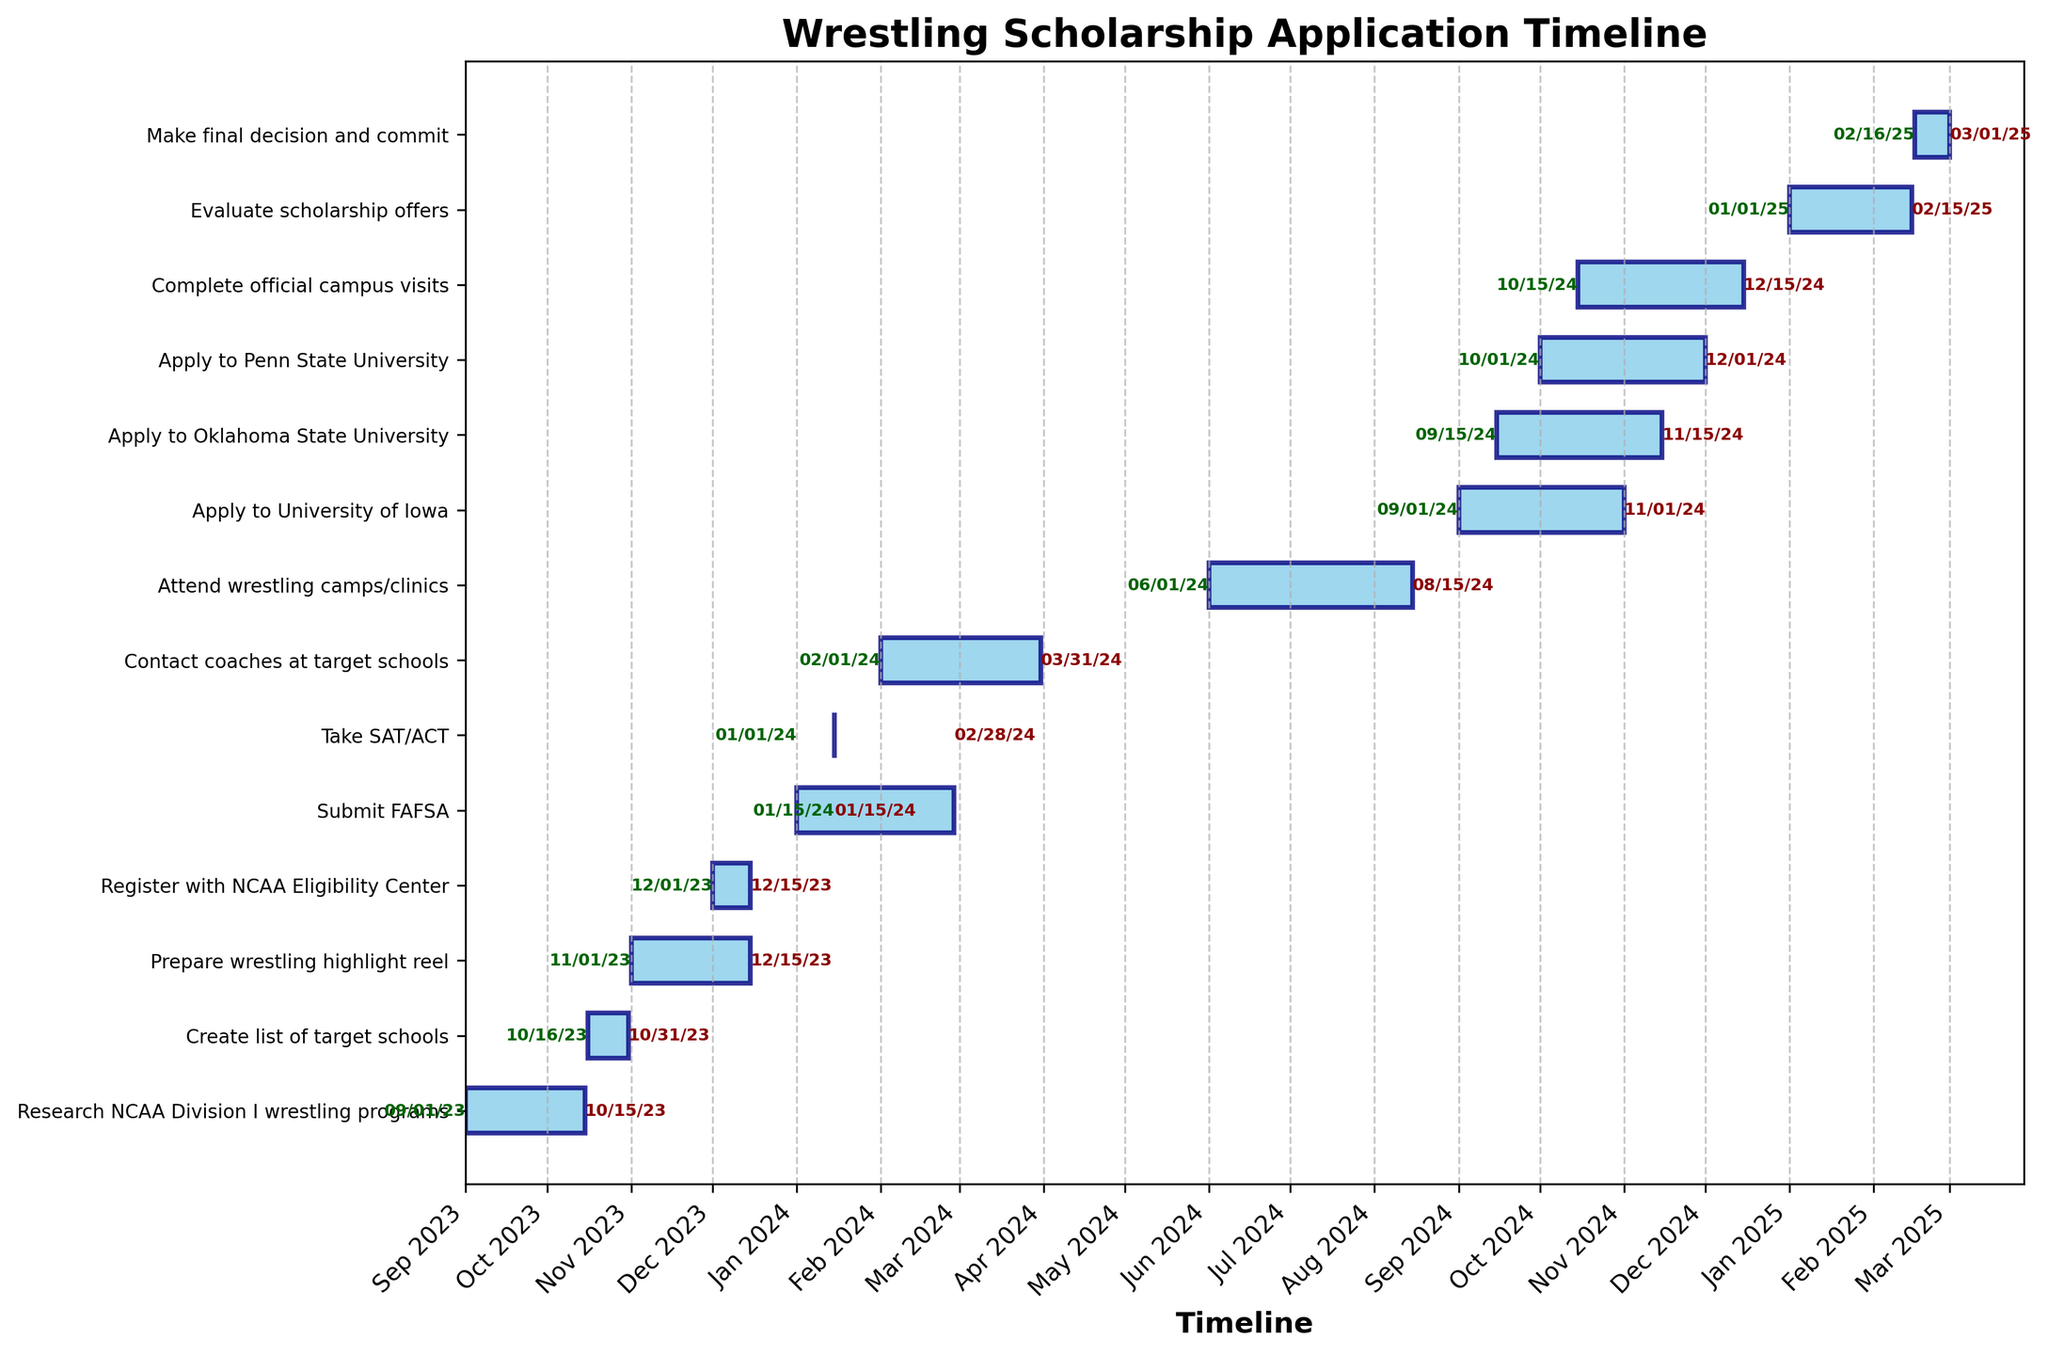Which task ends earliest? To determine the earliest ending task, check the end dates of all tasks and identify the one that occurs first on the timeline.
Answer: Research NCAA Division I wrestling programs What is the duration of preparing the wrestling highlight reel? Look at the start and end dates for "Prepare wrestling highlight reel" to calculate the duration. From 2023-11-01 to 2023-12-15 is 45 days.
Answer: 45 days How many tasks start in September 2024? To find the number of tasks starting in September 2024, check the start dates and count the tasks starting within that month.
Answer: 1 Which task starts right after registering with NCAA Eligibility Center? Look at the end date of "Register with NCAA Eligibility Center" and find the next task that starts immediately after this end date. "Take SAT/ACT" starts on 2024-01-15, following the end date of 2023-12-15 for NCAA Eligibility Center registration.
Answer: Take SAT/ACT Which task has the longest duration? Compare all the durations of each task. "Submit FAFSA" has the longest duration from 2024-01-01 to 2024-02-28, which is 59 days.
Answer: Submit FAFSA How many tasks overlap in the month of October 2024? Identify tasks that are active during October 2024 by checking their start and end dates and count them.
Answer: 3 Which application is due last, University of Iowa, Oklahoma State University, or Penn State University? Compare the end dates of the applications for these universities. Penn State University's application ends last on 2024-12-01.
Answer: Penn State University What is the gap between contacting coaches at target schools and attending wrestling camps/clinics? Calculate the difference between the end date of "Contact coaches at target schools" (2024-03-31) and the start date of "Attend wrestling camps/clinics" (2024-06-01). The gap is 62 days.
Answer: 62 days Which tasks occur simultaneously in December 2024? Check which tasks have overlapping or common dates in December 2024. "Apply to Penn State University" and "Complete official campus visits" both occur during this month.
Answer: Apply to Penn State University and Complete official campus visits What is the total time span from the start of the first task to the end of the last task? Find the start date of the first task (Research NCAA Division I wrestling programs, 2023-09-01) and the end date of the last task (Make final decision and commit, 2025-03-01). The total span is from 2023-09-01 to 2025-03-01, which is 548 days.
Answer: 548 days 